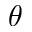<formula> <loc_0><loc_0><loc_500><loc_500>\theta</formula> 